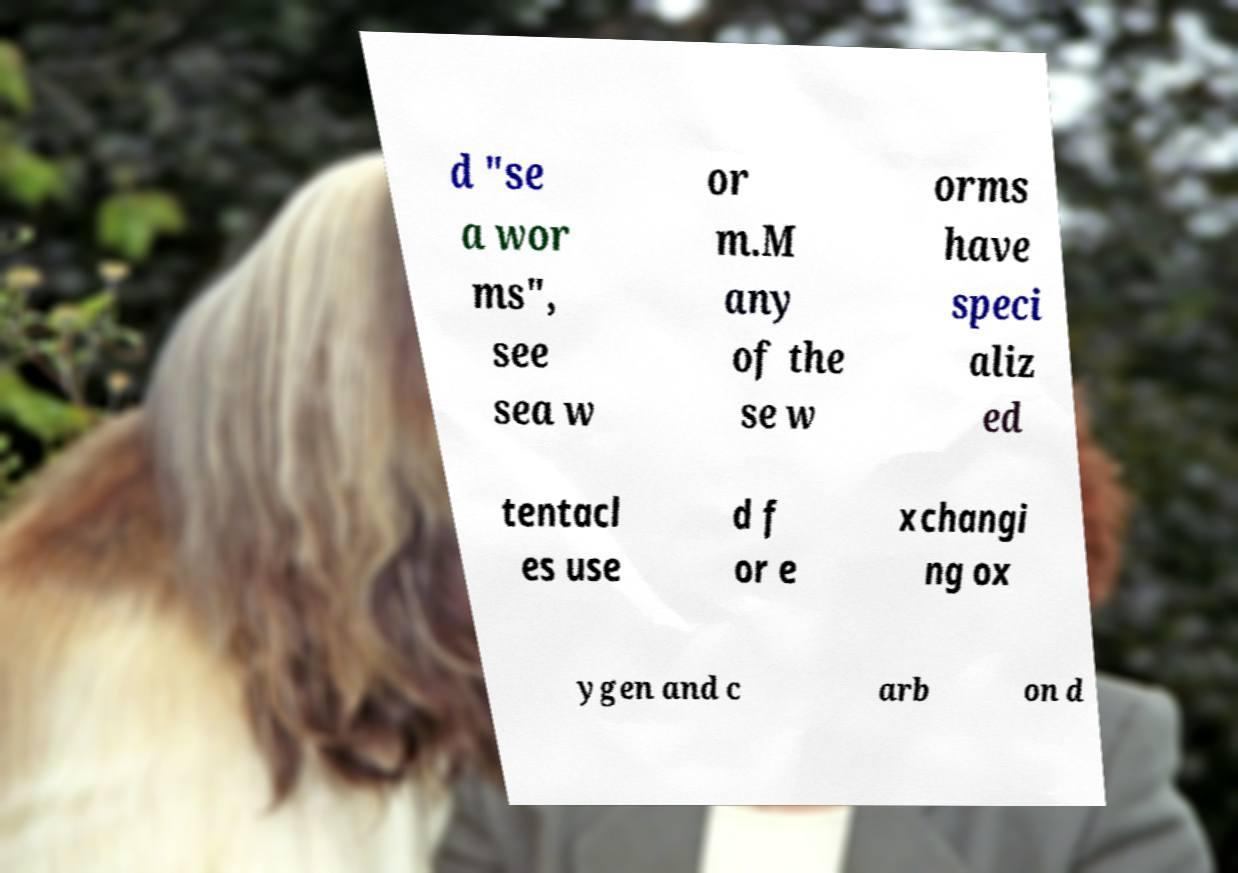I need the written content from this picture converted into text. Can you do that? d "se a wor ms", see sea w or m.M any of the se w orms have speci aliz ed tentacl es use d f or e xchangi ng ox ygen and c arb on d 